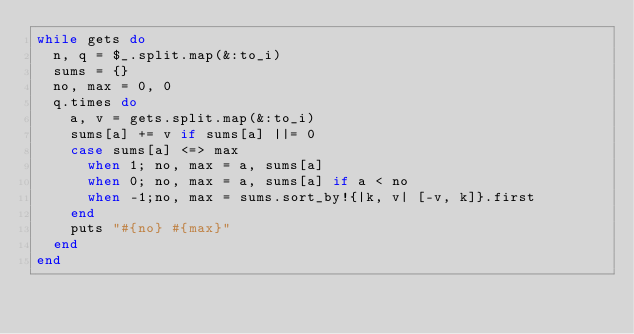Convert code to text. <code><loc_0><loc_0><loc_500><loc_500><_Ruby_>while gets do
  n, q = $_.split.map(&:to_i)
  sums = {}
  no, max = 0, 0
  q.times do
    a, v = gets.split.map(&:to_i)
    sums[a] += v if sums[a] ||= 0
    case sums[a] <=> max
      when 1; no, max = a, sums[a]
      when 0; no, max = a, sums[a] if a < no
      when -1;no, max = sums.sort_by!{|k, v| [-v, k]}.first
    end
    puts "#{no} #{max}"
  end
end</code> 